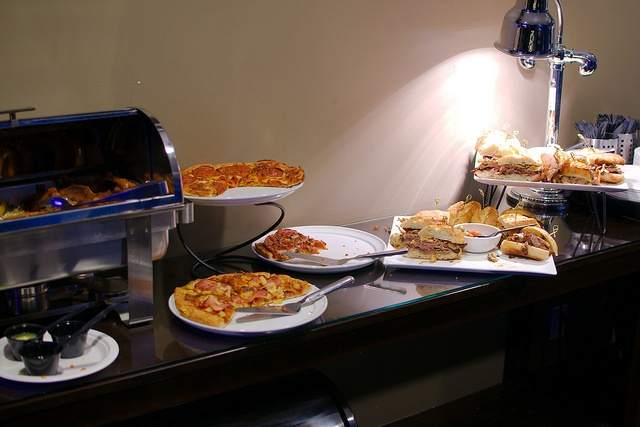Describe the objects in this image and their specific colors. I can see pizza in gray, red, maroon, orange, and tan tones, pizza in gray, brown, maroon, and orange tones, sandwich in gray, tan, and brown tones, sandwich in gray, ivory, red, and tan tones, and sandwich in gray, brown, tan, and maroon tones in this image. 